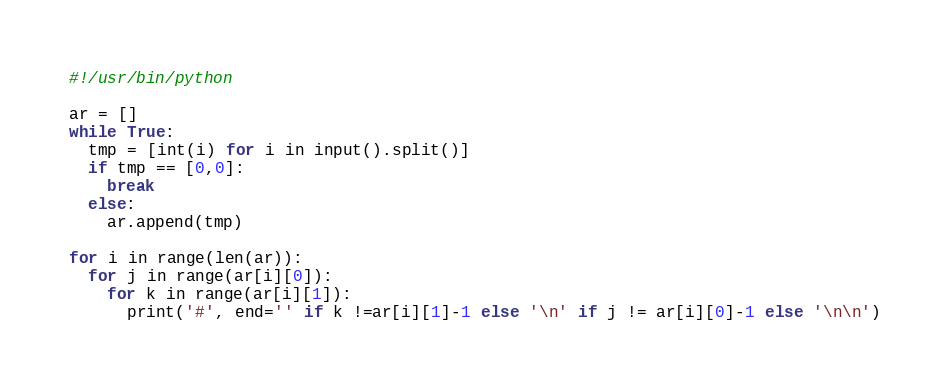<code> <loc_0><loc_0><loc_500><loc_500><_Python_>#!/usr/bin/python

ar = []
while True:
  tmp = [int(i) for i in input().split()]
  if tmp == [0,0]:
    break
  else:
    ar.append(tmp)

for i in range(len(ar)):
  for j in range(ar[i][0]):
    for k in range(ar[i][1]):
      print('#', end='' if k !=ar[i][1]-1 else '\n' if j != ar[i][0]-1 else '\n\n')</code> 